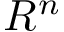Convert formula to latex. <formula><loc_0><loc_0><loc_500><loc_500>R ^ { n }</formula> 